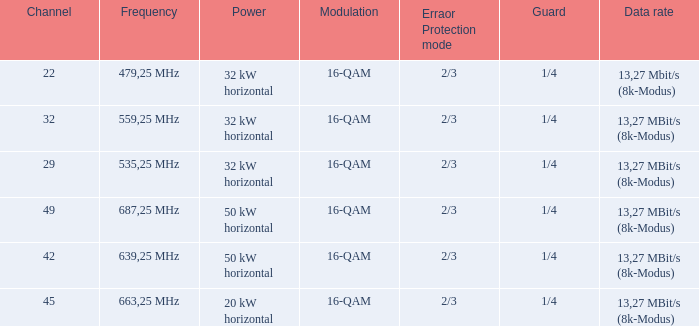On channel 32, when the power is 32 kW horizontal, what is the frequency? 559,25 MHz. 